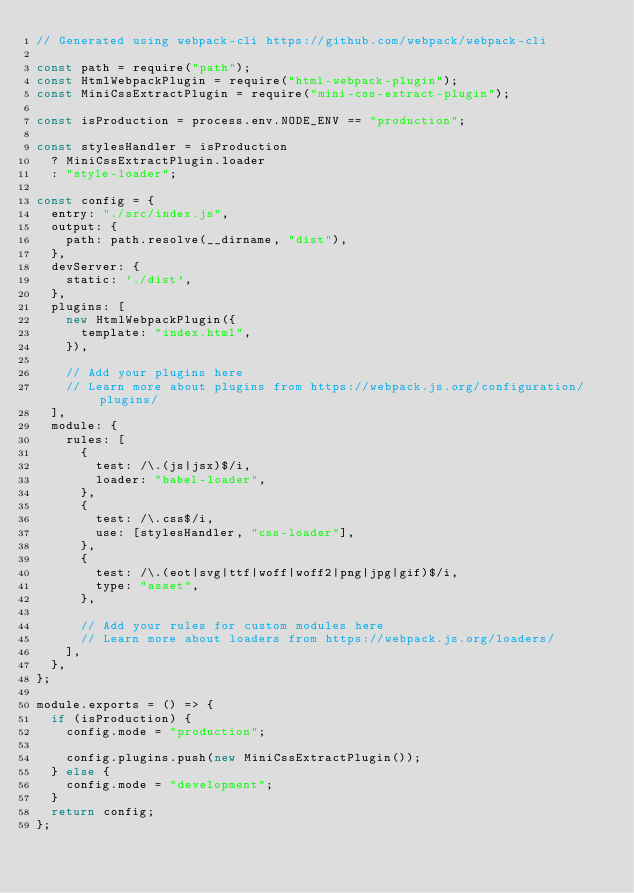<code> <loc_0><loc_0><loc_500><loc_500><_JavaScript_>// Generated using webpack-cli https://github.com/webpack/webpack-cli

const path = require("path");
const HtmlWebpackPlugin = require("html-webpack-plugin");
const MiniCssExtractPlugin = require("mini-css-extract-plugin");

const isProduction = process.env.NODE_ENV == "production";

const stylesHandler = isProduction
  ? MiniCssExtractPlugin.loader
  : "style-loader";

const config = {
  entry: "./src/index.js",
  output: {
    path: path.resolve(__dirname, "dist"),
  },
  devServer: {
    static: './dist',
  },
  plugins: [
    new HtmlWebpackPlugin({
      template: "index.html",
    }),

    // Add your plugins here
    // Learn more about plugins from https://webpack.js.org/configuration/plugins/
  ],
  module: {
    rules: [
      {
        test: /\.(js|jsx)$/i,
        loader: "babel-loader",
      },
      {
        test: /\.css$/i,
        use: [stylesHandler, "css-loader"],
      },
      {
        test: /\.(eot|svg|ttf|woff|woff2|png|jpg|gif)$/i,
        type: "asset",
      },

      // Add your rules for custom modules here
      // Learn more about loaders from https://webpack.js.org/loaders/
    ],
  },
};

module.exports = () => {
  if (isProduction) {
    config.mode = "production";

    config.plugins.push(new MiniCssExtractPlugin());
  } else {
    config.mode = "development";
  }
  return config;
};
</code> 